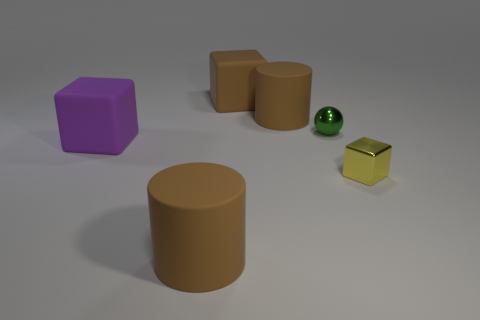Subtract all large rubber blocks. How many blocks are left? 1 Subtract all balls. How many objects are left? 5 Subtract all purple blocks. How many blocks are left? 2 Add 3 large green spheres. How many objects exist? 9 Add 6 green metal spheres. How many green metal spheres exist? 7 Subtract 0 red cylinders. How many objects are left? 6 Subtract 2 cylinders. How many cylinders are left? 0 Subtract all red spheres. Subtract all red blocks. How many spheres are left? 1 Subtract all yellow balls. How many yellow blocks are left? 1 Subtract all cyan matte objects. Subtract all tiny yellow metallic blocks. How many objects are left? 5 